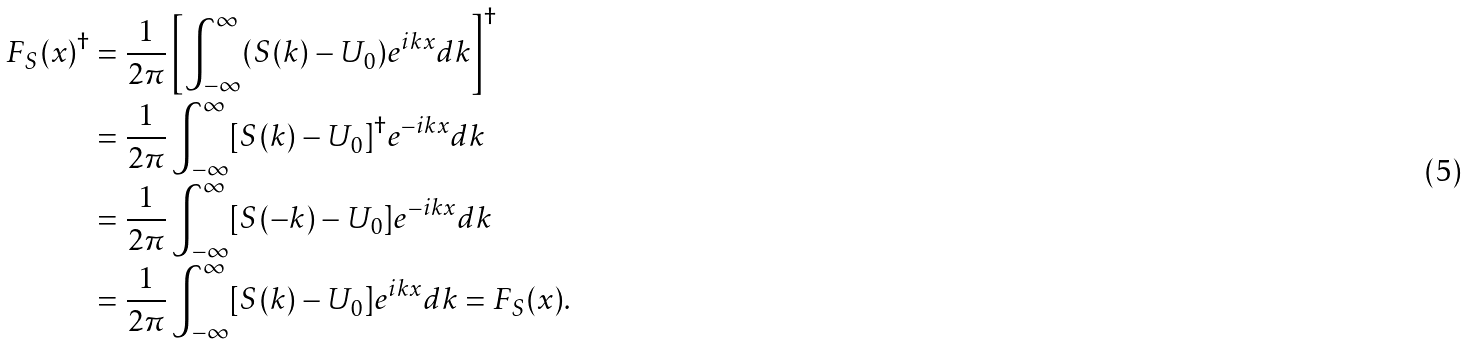Convert formula to latex. <formula><loc_0><loc_0><loc_500><loc_500>F _ { S } ( x ) ^ { \dagger } & = \frac { 1 } { 2 \pi } \left [ \int _ { - \infty } ^ { \infty } ( S ( k ) - { U _ { 0 } } ) e ^ { i k x } d k \right ] ^ { \dag } \\ & = \frac { 1 } { 2 \pi } \int _ { - \infty } ^ { \infty } [ S ( k ) - { U _ { 0 } } ] ^ { \dag } e ^ { - i k x } d k \\ & = \frac { 1 } { 2 \pi } \int _ { - \infty } ^ { \infty } [ S ( - k ) - { U _ { 0 } } ] e ^ { - i k x } d k \\ & = \frac { 1 } { 2 \pi } \int _ { - \infty } ^ { \infty } [ S ( k ) - { U _ { 0 } } ] e ^ { i k x } d k = F _ { S } ( x ) .</formula> 